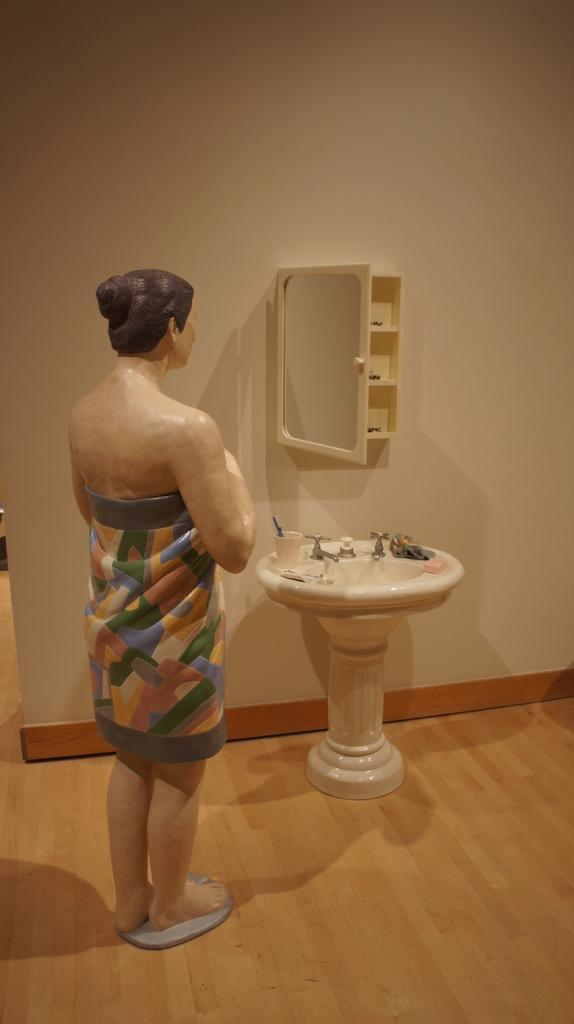Describe this image in one or two sentences. In this image we can see a statue on the floor, in front of the statue we can see a wash basin with taps and few objects on it. And there is a box with mirror and racks attached to the wall. 